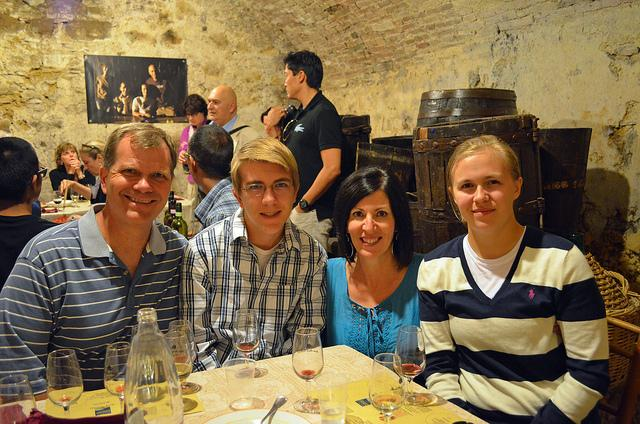What pattern is the young guy's shirt?

Choices:
A) stripes
B) tartan
C) checked
D) plaid plaid 